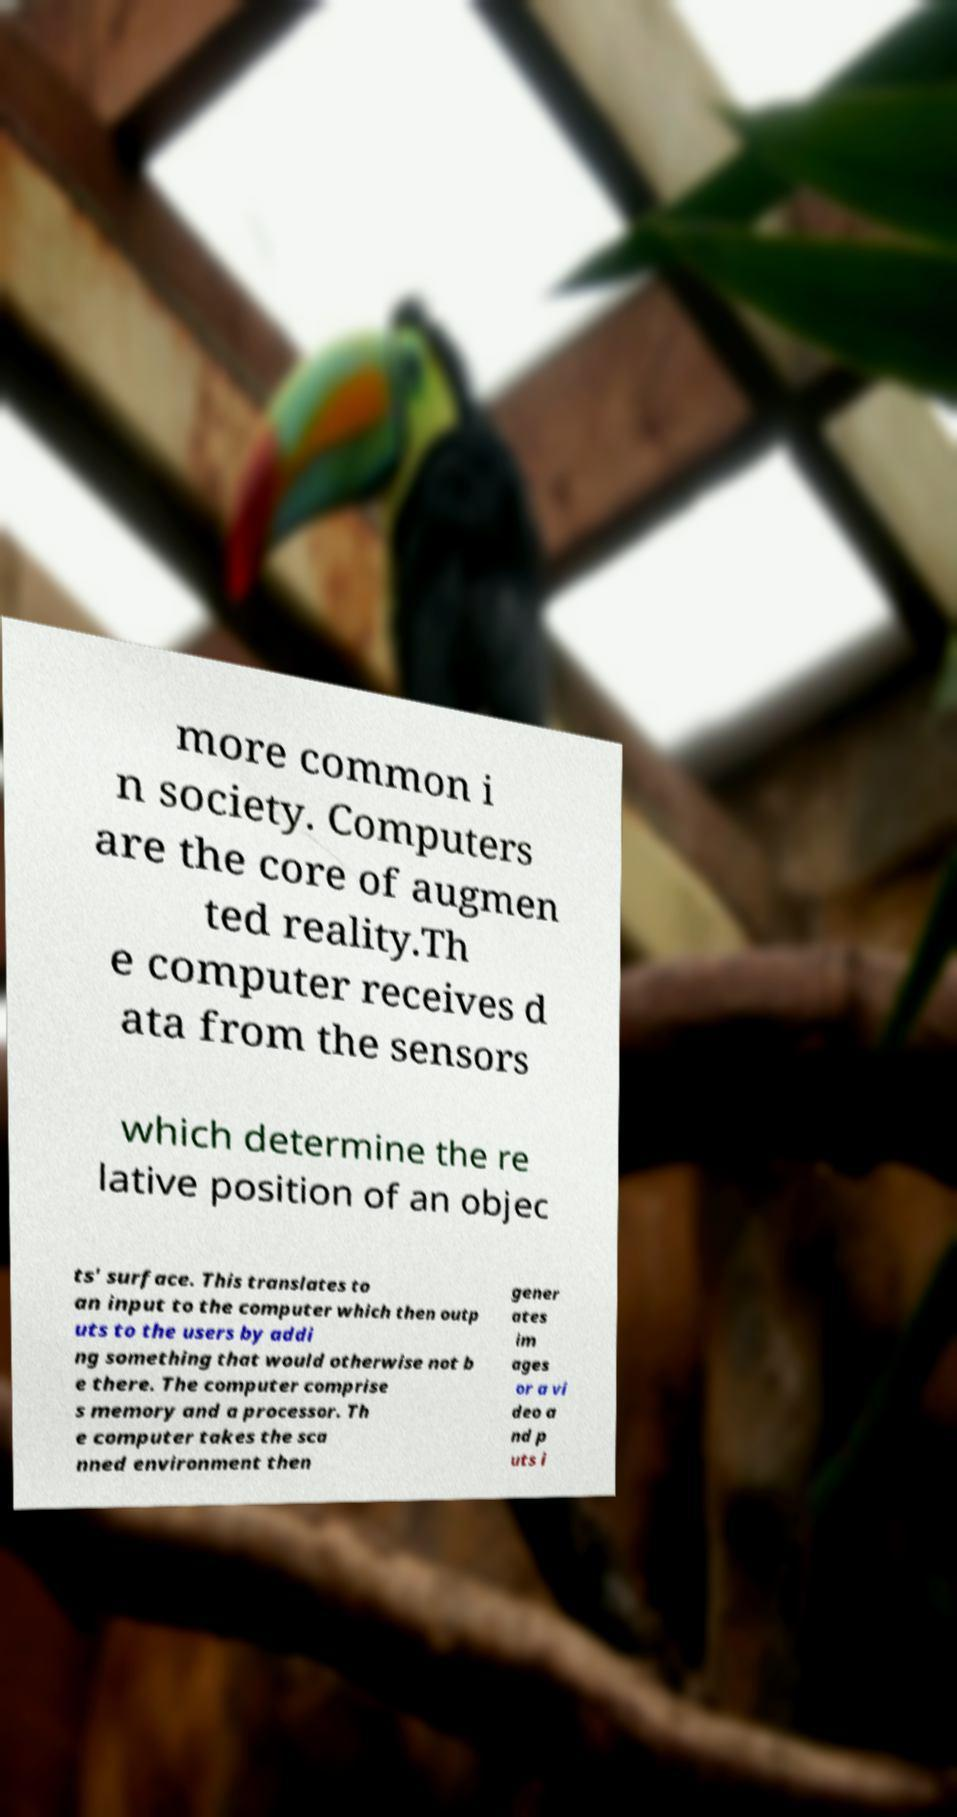Please read and relay the text visible in this image. What does it say? more common i n society. Computers are the core of augmen ted reality.Th e computer receives d ata from the sensors which determine the re lative position of an objec ts' surface. This translates to an input to the computer which then outp uts to the users by addi ng something that would otherwise not b e there. The computer comprise s memory and a processor. Th e computer takes the sca nned environment then gener ates im ages or a vi deo a nd p uts i 